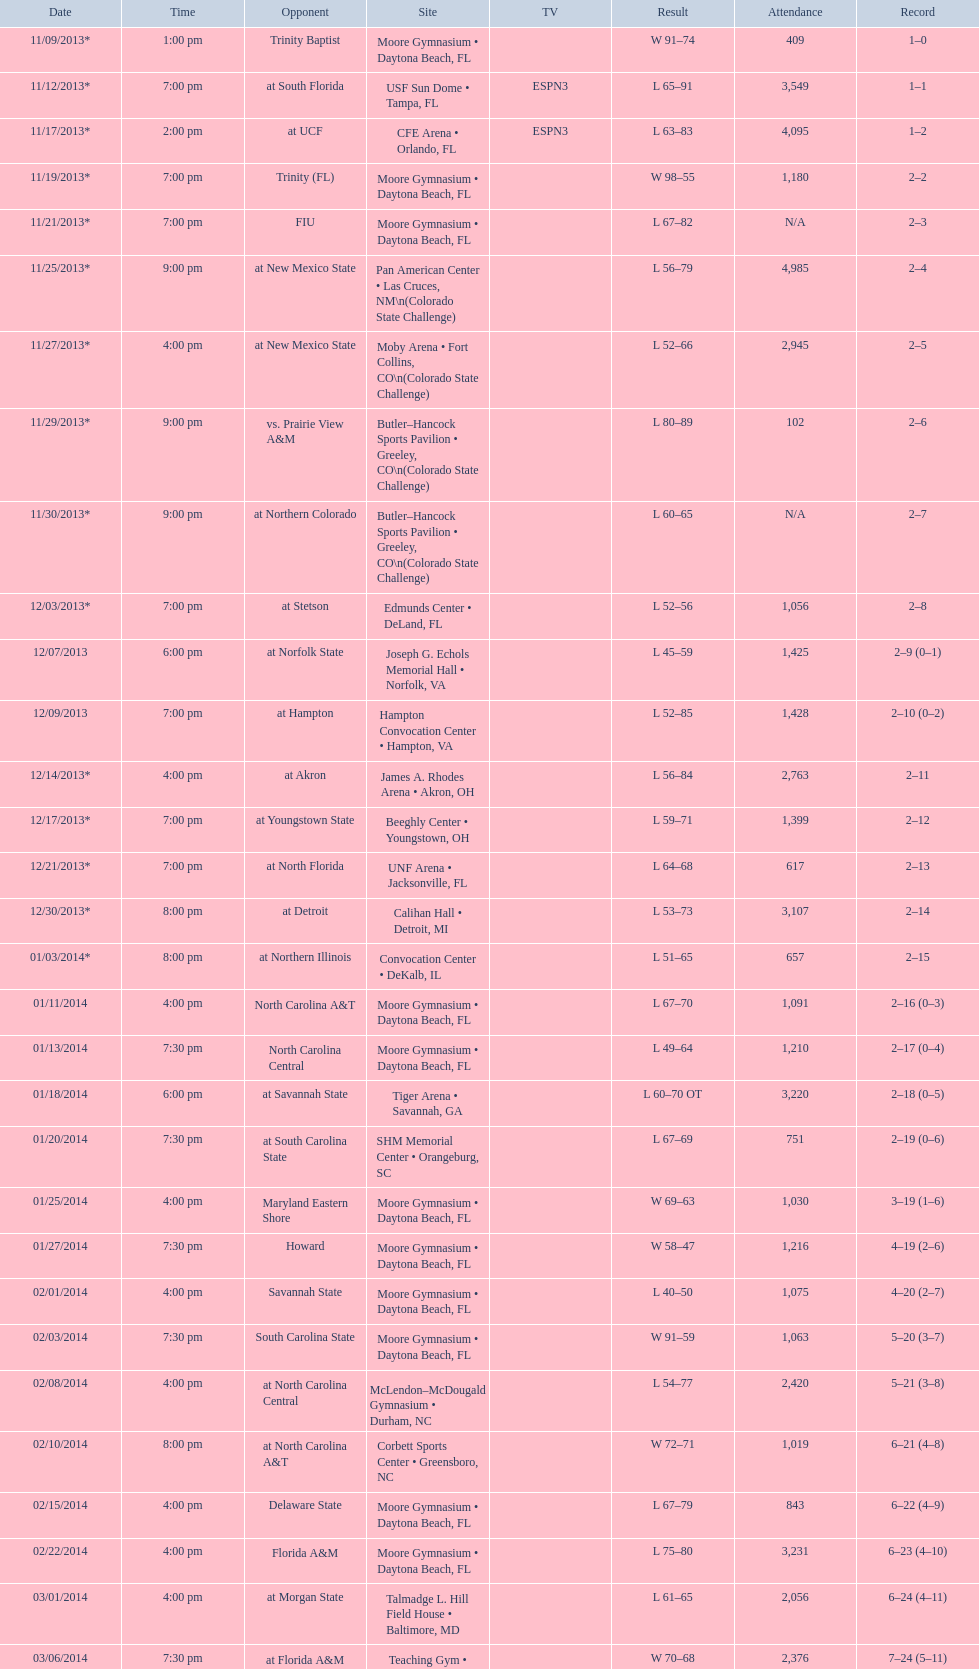In daytona beach, fl, how many games were participated in by the wildcats? 11. 